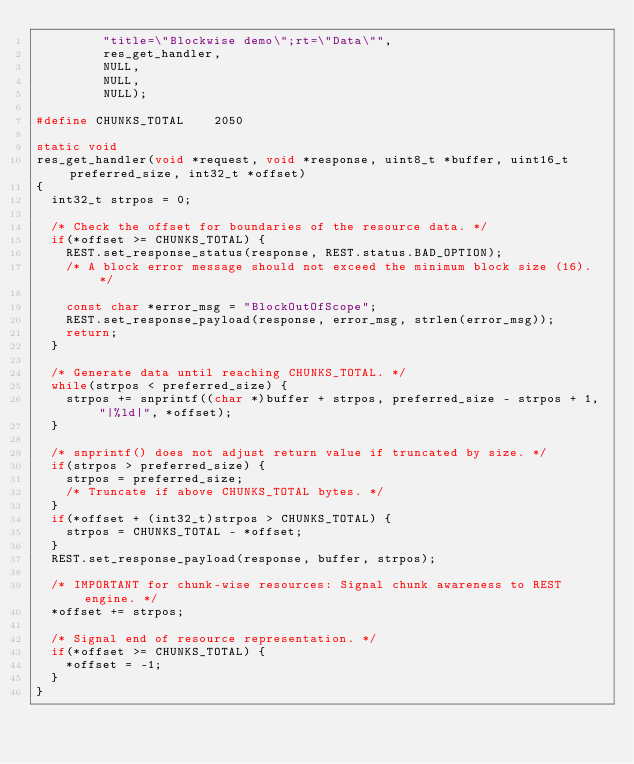<code> <loc_0><loc_0><loc_500><loc_500><_C_>         "title=\"Blockwise demo\";rt=\"Data\"",
         res_get_handler,
         NULL,
         NULL,
         NULL);

#define CHUNKS_TOTAL    2050

static void
res_get_handler(void *request, void *response, uint8_t *buffer, uint16_t preferred_size, int32_t *offset)
{
  int32_t strpos = 0;

  /* Check the offset for boundaries of the resource data. */
  if(*offset >= CHUNKS_TOTAL) {
    REST.set_response_status(response, REST.status.BAD_OPTION);
    /* A block error message should not exceed the minimum block size (16). */

    const char *error_msg = "BlockOutOfScope";
    REST.set_response_payload(response, error_msg, strlen(error_msg));
    return;
  }

  /* Generate data until reaching CHUNKS_TOTAL. */
  while(strpos < preferred_size) {
    strpos += snprintf((char *)buffer + strpos, preferred_size - strpos + 1, "|%ld|", *offset);
  }

  /* snprintf() does not adjust return value if truncated by size. */
  if(strpos > preferred_size) {
    strpos = preferred_size;
    /* Truncate if above CHUNKS_TOTAL bytes. */
  }
  if(*offset + (int32_t)strpos > CHUNKS_TOTAL) {
    strpos = CHUNKS_TOTAL - *offset;
  }
  REST.set_response_payload(response, buffer, strpos);

  /* IMPORTANT for chunk-wise resources: Signal chunk awareness to REST engine. */
  *offset += strpos;

  /* Signal end of resource representation. */
  if(*offset >= CHUNKS_TOTAL) {
    *offset = -1;
  }
}
</code> 